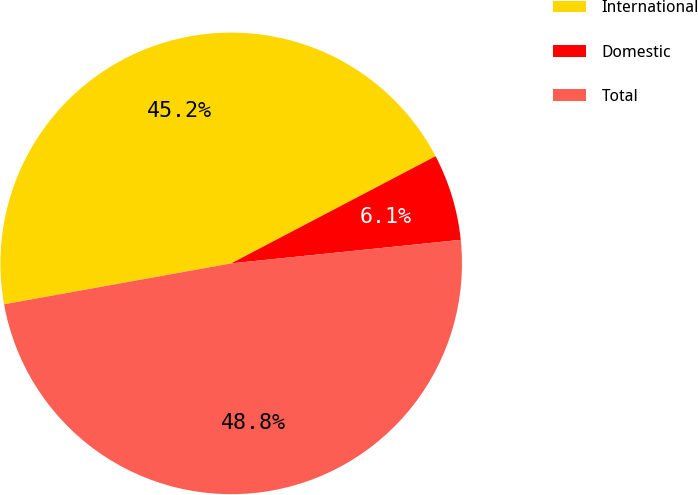Convert chart. <chart><loc_0><loc_0><loc_500><loc_500><pie_chart><fcel>International<fcel>Domestic<fcel>Total<nl><fcel>45.15%<fcel>6.06%<fcel>48.79%<nl></chart> 